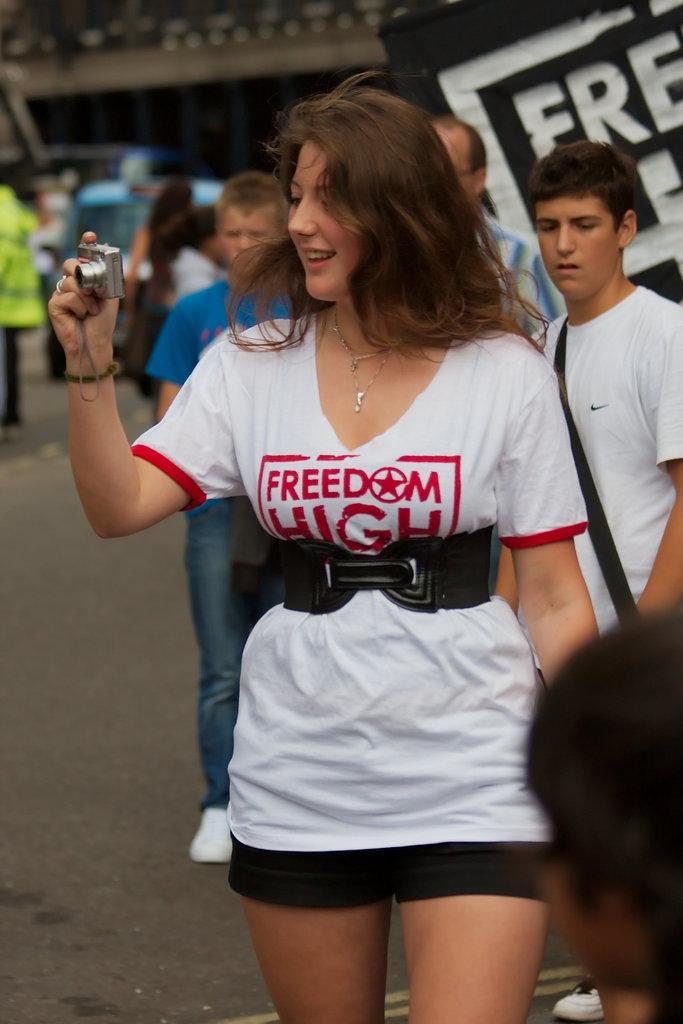<image>
Render a clear and concise summary of the photo. Freedom high protector holding a camera walking down the street 